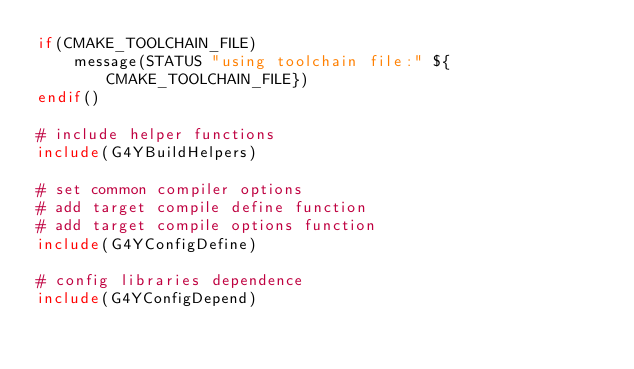<code> <loc_0><loc_0><loc_500><loc_500><_CMake_>if(CMAKE_TOOLCHAIN_FILE)
    message(STATUS "using toolchain file:" ${CMAKE_TOOLCHAIN_FILE})
endif()

# include helper functions
include(G4YBuildHelpers)

# set common compiler options
# add target compile define function
# add target compile options function
include(G4YConfigDefine)

# config libraries dependence
include(G4YConfigDepend)</code> 